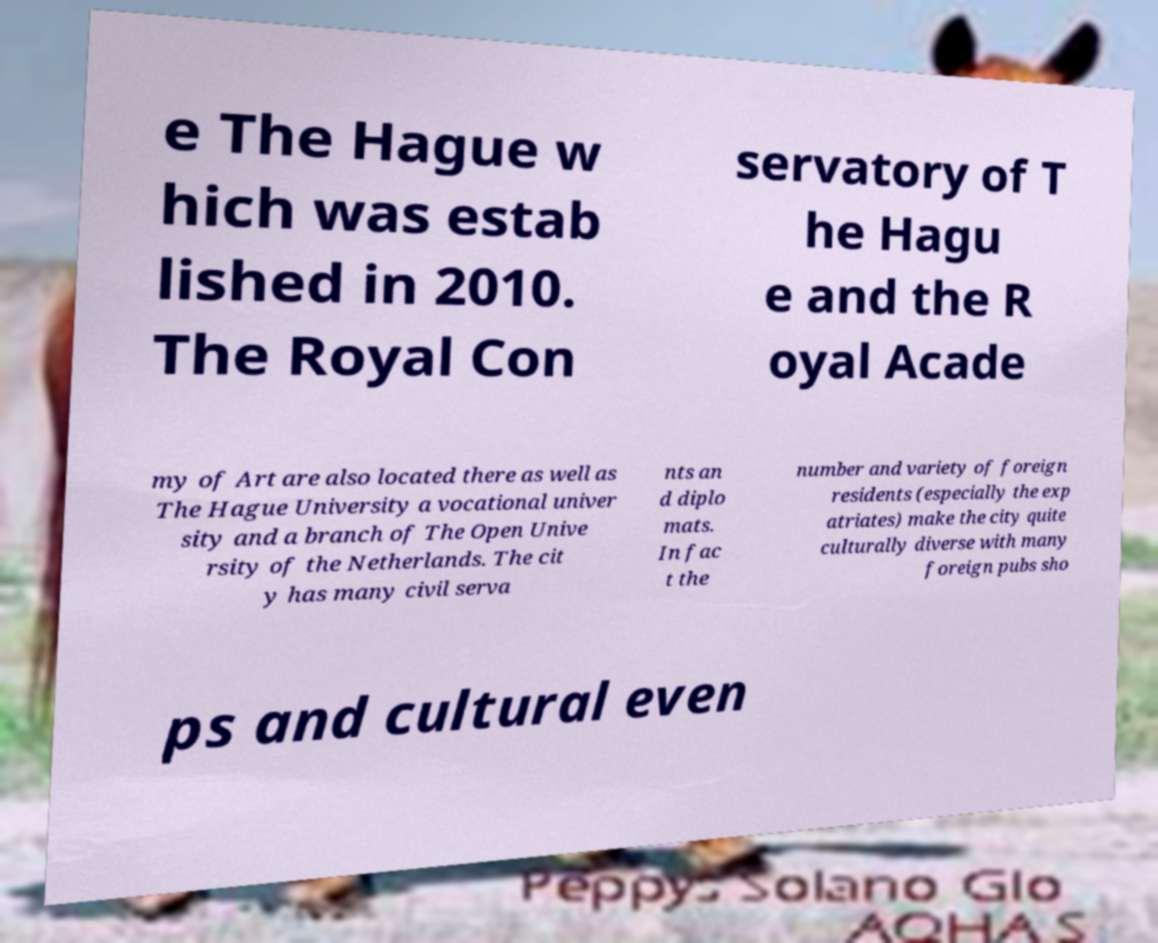Please read and relay the text visible in this image. What does it say? e The Hague w hich was estab lished in 2010. The Royal Con servatory of T he Hagu e and the R oyal Acade my of Art are also located there as well as The Hague University a vocational univer sity and a branch of The Open Unive rsity of the Netherlands. The cit y has many civil serva nts an d diplo mats. In fac t the number and variety of foreign residents (especially the exp atriates) make the city quite culturally diverse with many foreign pubs sho ps and cultural even 